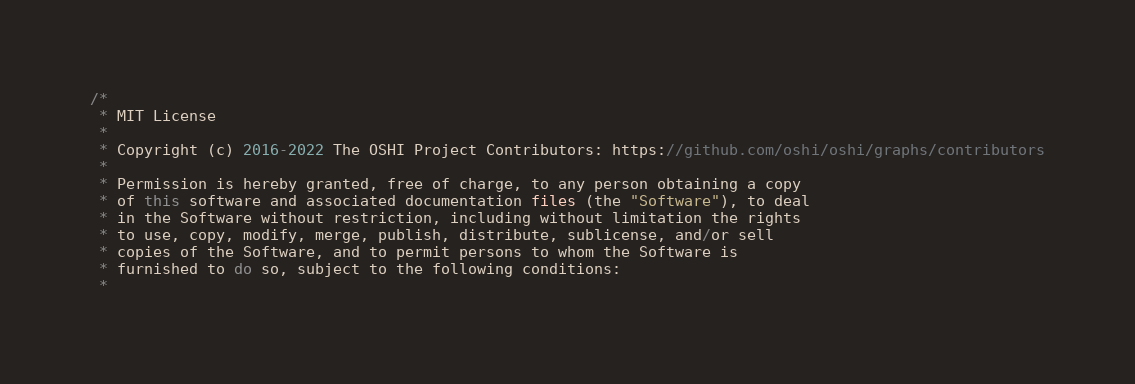Convert code to text. <code><loc_0><loc_0><loc_500><loc_500><_Java_>/*
 * MIT License
 *
 * Copyright (c) 2016-2022 The OSHI Project Contributors: https://github.com/oshi/oshi/graphs/contributors
 *
 * Permission is hereby granted, free of charge, to any person obtaining a copy
 * of this software and associated documentation files (the "Software"), to deal
 * in the Software without restriction, including without limitation the rights
 * to use, copy, modify, merge, publish, distribute, sublicense, and/or sell
 * copies of the Software, and to permit persons to whom the Software is
 * furnished to do so, subject to the following conditions:
 *</code> 